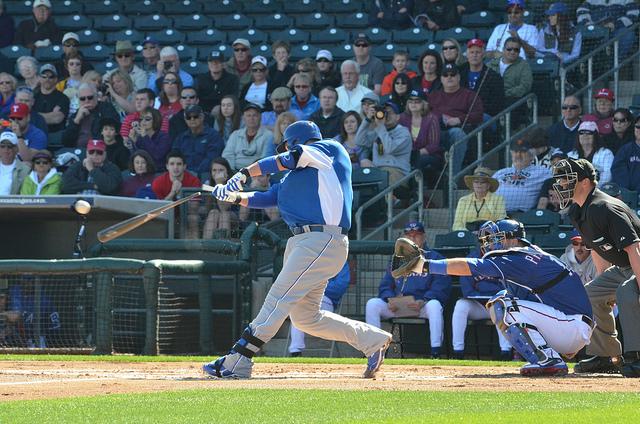Where is the baseball?
Be succinct. In air. Why is the man in black there?
Concise answer only. Umpire. What game are they playing?
Keep it brief. Baseball. Did the batter get a hit?
Short answer required. Yes. Are the stands full at this game?
Give a very brief answer. No. 